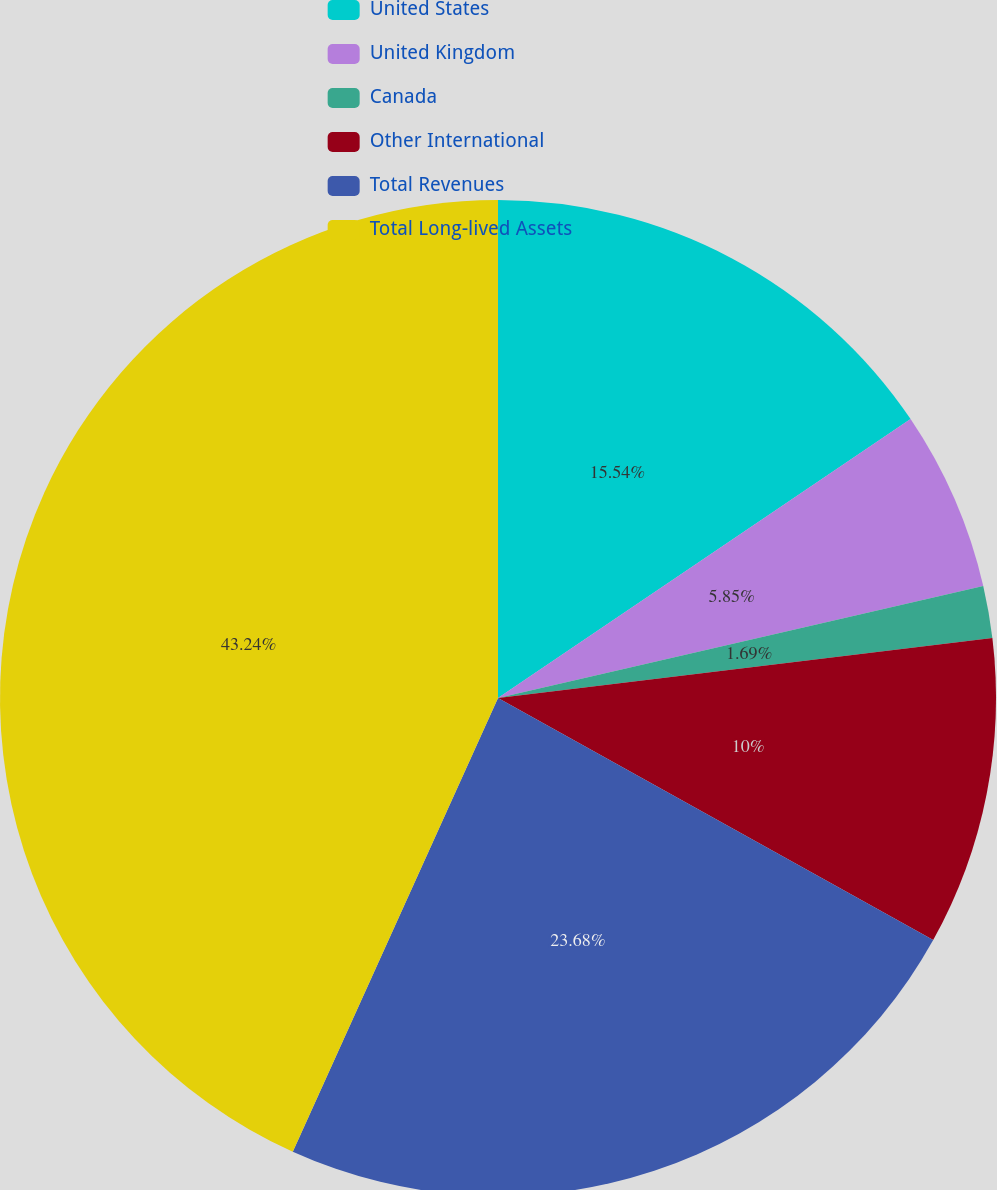Convert chart. <chart><loc_0><loc_0><loc_500><loc_500><pie_chart><fcel>United States<fcel>United Kingdom<fcel>Canada<fcel>Other International<fcel>Total Revenues<fcel>Total Long-lived Assets<nl><fcel>15.54%<fcel>5.85%<fcel>1.69%<fcel>10.0%<fcel>23.68%<fcel>43.24%<nl></chart> 